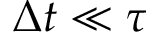<formula> <loc_0><loc_0><loc_500><loc_500>\Delta t \ll \tau</formula> 